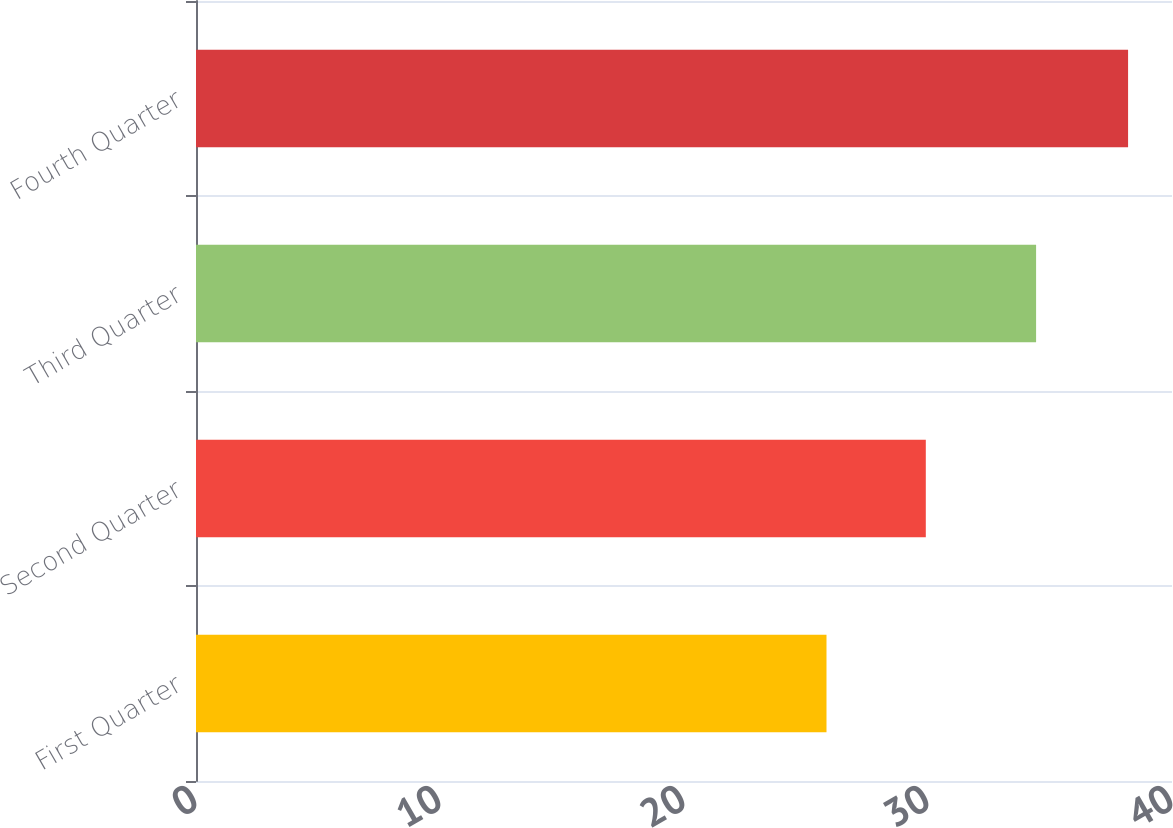Convert chart to OTSL. <chart><loc_0><loc_0><loc_500><loc_500><bar_chart><fcel>First Quarter<fcel>Second Quarter<fcel>Third Quarter<fcel>Fourth Quarter<nl><fcel>25.84<fcel>29.91<fcel>34.43<fcel>38.2<nl></chart> 